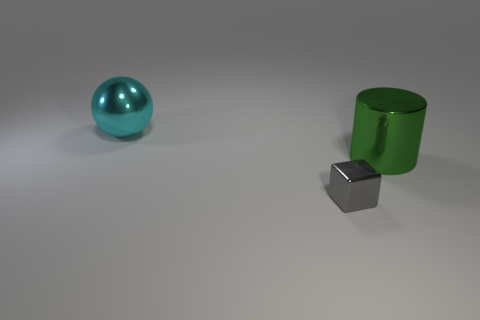Is there any other thing that has the same shape as the small gray thing? Although the objects in the image vary in shape, the small gray cube shares a similarity in geometry with the green cylinder, in that they both have flat surfaces and edges. However, none of the objects has the exact same three-dimensional cube shape. 